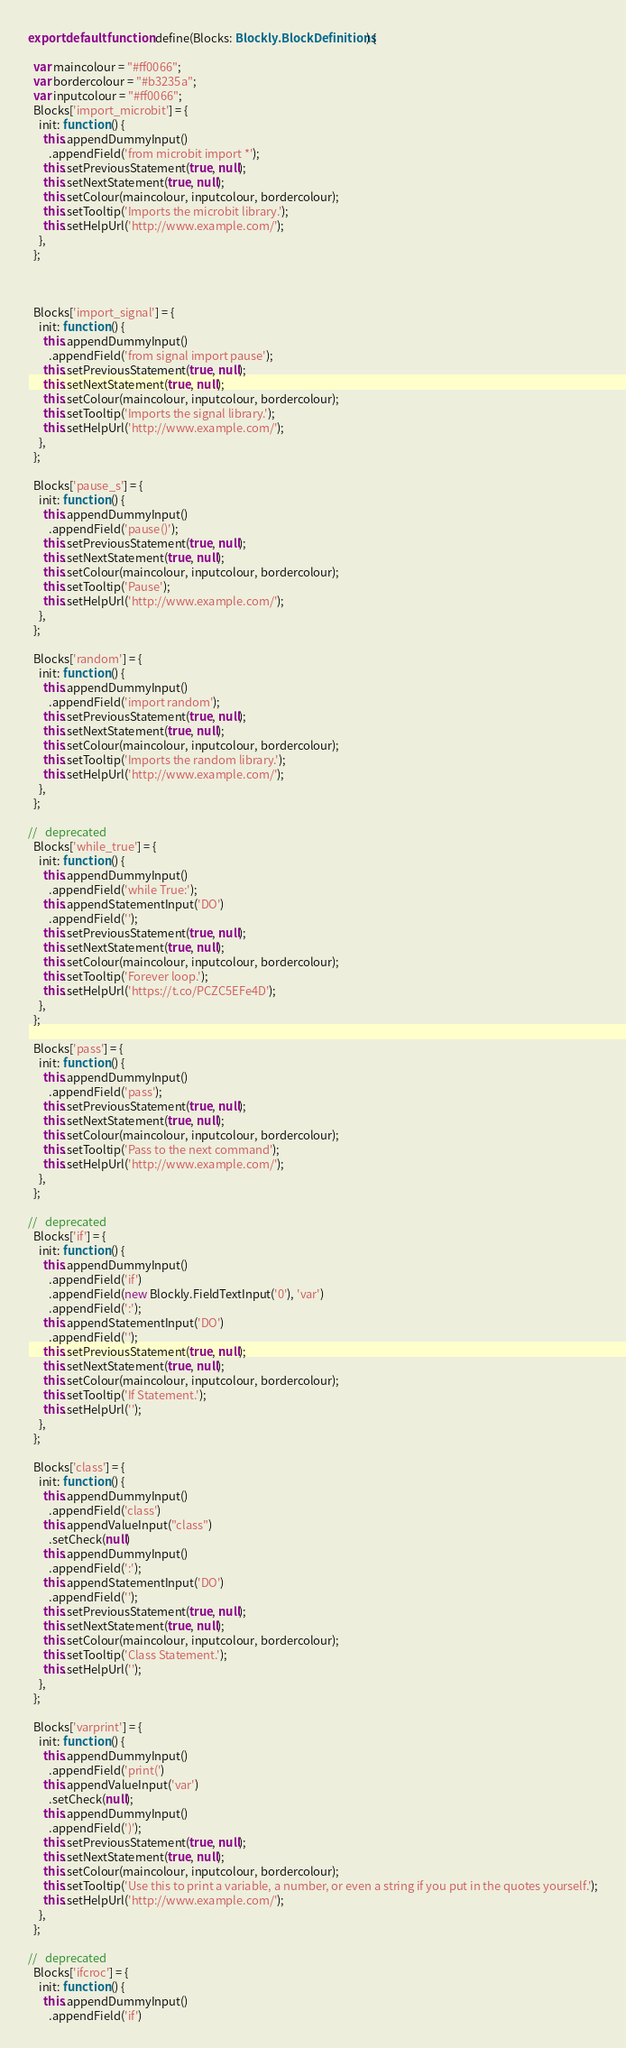<code> <loc_0><loc_0><loc_500><loc_500><_TypeScript_>export default function define(Blocks: Blockly.BlockDefinitions) {

  var maincolour = "#ff0066";
  var bordercolour = "#b3235a";
  var inputcolour = "#ff0066";
  Blocks['import_microbit'] = {
    init: function () {
      this.appendDummyInput()
        .appendField('from microbit import *');
      this.setPreviousStatement(true, null);
      this.setNextStatement(true, null);
      this.setColour(maincolour, inputcolour, bordercolour);
      this.setTooltip('Imports the microbit library.');
      this.setHelpUrl('http://www.example.com/');
    },
  };

  

  Blocks['import_signal'] = {
    init: function () {
      this.appendDummyInput()
        .appendField('from signal import pause');
      this.setPreviousStatement(true, null);
      this.setNextStatement(true, null);
      this.setColour(maincolour, inputcolour, bordercolour);
      this.setTooltip('Imports the signal library.');
      this.setHelpUrl('http://www.example.com/');
    },
  };

  Blocks['pause_s'] = {
    init: function () {
      this.appendDummyInput()
        .appendField('pause()');
      this.setPreviousStatement(true, null);
      this.setNextStatement(true, null);
      this.setColour(maincolour, inputcolour, bordercolour);
      this.setTooltip('Pause');
      this.setHelpUrl('http://www.example.com/');
    },
  };

  Blocks['random'] = {
    init: function () {
      this.appendDummyInput()
        .appendField('import random');
      this.setPreviousStatement(true, null);
      this.setNextStatement(true, null);
      this.setColour(maincolour, inputcolour, bordercolour);
      this.setTooltip('Imports the random library.');
      this.setHelpUrl('http://www.example.com/');
    },
  };

//   deprecated
  Blocks['while_true'] = {
    init: function () {
      this.appendDummyInput()
        .appendField('while True:');
      this.appendStatementInput('DO')
        .appendField('');
      this.setPreviousStatement(true, null);
      this.setNextStatement(true, null);
      this.setColour(maincolour, inputcolour, bordercolour);
      this.setTooltip('Forever loop.');
      this.setHelpUrl('https://t.co/PCZC5EFe4D');
    },
  };

  Blocks['pass'] = {
    init: function () {
      this.appendDummyInput()
        .appendField('pass');
      this.setPreviousStatement(true, null);
      this.setNextStatement(true, null);
      this.setColour(maincolour, inputcolour, bordercolour);
      this.setTooltip('Pass to the next command');
      this.setHelpUrl('http://www.example.com/');
    },
  };

//   deprecated
  Blocks['if'] = {
    init: function () {
      this.appendDummyInput()
        .appendField('if')
        .appendField(new Blockly.FieldTextInput('0'), 'var')
        .appendField(':');
      this.appendStatementInput('DO')
        .appendField('');
      this.setPreviousStatement(true, null);
      this.setNextStatement(true, null);
      this.setColour(maincolour, inputcolour, bordercolour);
      this.setTooltip('If Statement.');
      this.setHelpUrl('');
    },
  };

  Blocks['class'] = {
    init: function () {
      this.appendDummyInput()
        .appendField('class')
      this.appendValueInput("class")
        .setCheck(null)
      this.appendDummyInput()
        .appendField(':');
      this.appendStatementInput('DO')
        .appendField('');
      this.setPreviousStatement(true, null);
      this.setNextStatement(true, null);
      this.setColour(maincolour, inputcolour, bordercolour);
      this.setTooltip('Class Statement.');
      this.setHelpUrl('');
    },
  };

  Blocks['varprint'] = {
    init: function () {
      this.appendDummyInput()
        .appendField('print(')
      this.appendValueInput('var')
        .setCheck(null);
      this.appendDummyInput()
        .appendField(')');
      this.setPreviousStatement(true, null);
      this.setNextStatement(true, null);
      this.setColour(maincolour, inputcolour, bordercolour);
      this.setTooltip('Use this to print a variable, a number, or even a string if you put in the quotes yourself.');
      this.setHelpUrl('http://www.example.com/');
    },
  };

//   deprecated
  Blocks['ifcroc'] = {
    init: function () {
      this.appendDummyInput()
        .appendField('if')</code> 